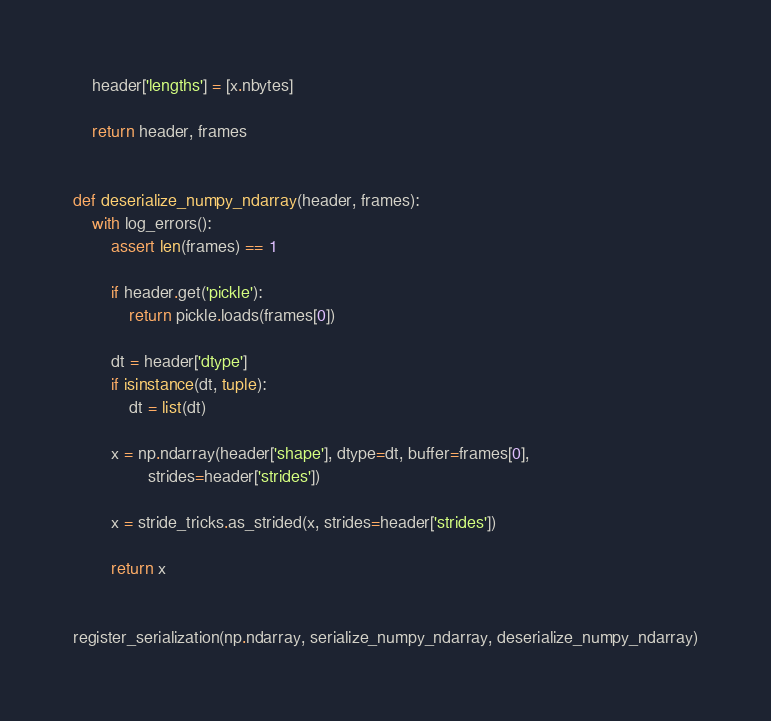<code> <loc_0><loc_0><loc_500><loc_500><_Python_>
    header['lengths'] = [x.nbytes]

    return header, frames


def deserialize_numpy_ndarray(header, frames):
    with log_errors():
        assert len(frames) == 1

        if header.get('pickle'):
            return pickle.loads(frames[0])

        dt = header['dtype']
        if isinstance(dt, tuple):
            dt = list(dt)

        x = np.ndarray(header['shape'], dtype=dt, buffer=frames[0],
                strides=header['strides'])

        x = stride_tricks.as_strided(x, strides=header['strides'])

        return x


register_serialization(np.ndarray, serialize_numpy_ndarray, deserialize_numpy_ndarray)
</code> 